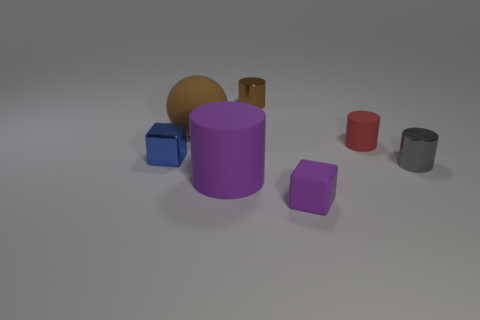What number of other big cylinders have the same material as the purple cylinder?
Make the answer very short. 0. There is a large rubber ball; does it have the same color as the object on the right side of the tiny red rubber object?
Your answer should be very brief. No. The large object that is in front of the metallic cylinder in front of the brown metallic object is what color?
Offer a very short reply. Purple. The rubber thing that is the same size as the rubber cube is what color?
Make the answer very short. Red. Is there another matte object that has the same shape as the small blue object?
Give a very brief answer. Yes. The blue shiny thing is what shape?
Provide a succinct answer. Cube. Are there more tiny purple things on the left side of the tiny purple matte block than small brown shiny cylinders on the right side of the red object?
Provide a succinct answer. No. How many other objects are there of the same size as the gray shiny cylinder?
Your answer should be very brief. 4. There is a tiny thing that is in front of the shiny cube and left of the red thing; what is its material?
Your answer should be compact. Rubber. There is a purple thing that is the same shape as the brown metal thing; what is it made of?
Provide a short and direct response. Rubber. 